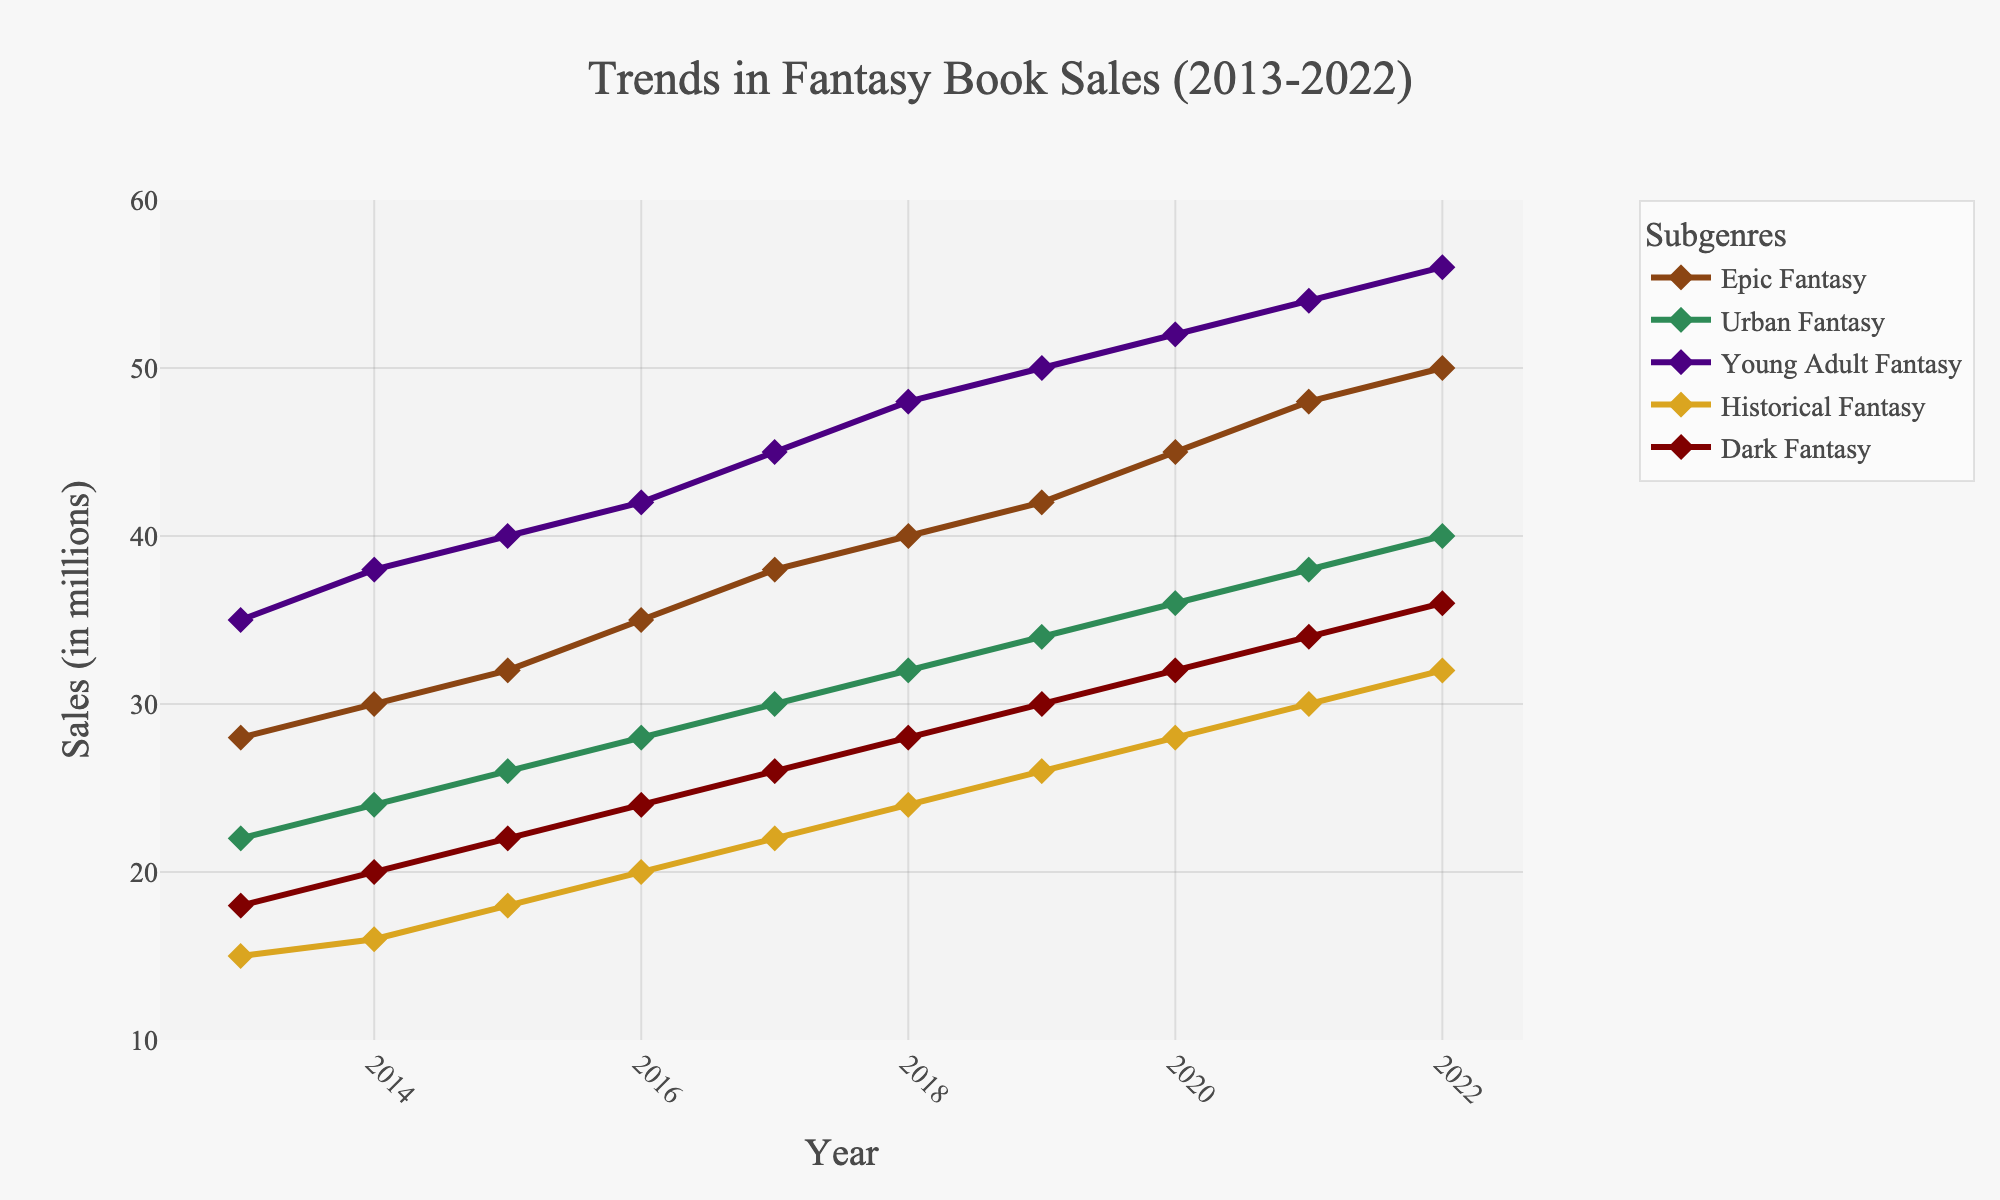What's the trend of Epic Fantasy sales from 2013 to 2022? The data for Epic Fantasy sales shows a steady increase over the years from 28 million in 2013 to 50 million in 2022. This indicates a positive trend.
Answer: Positive trend Which subgenre had the highest sales in 2016? Looking at the figure, the subgenre with the highest sales in 2016 is Young Adult Fantasy with sales of 42 million.
Answer: Young Adult Fantasy By how much did Urban Fantasy sales increase from 2013 to 2022? Urban Fantasy sales increased from 22 million in 2013 to 40 million in 2022. Thus, the increase is: 40 - 22 = 18 million.
Answer: 18 million Compare the sales of Historical Fantasy and Dark Fantasy in 2018. Which was higher and by how much? In 2018, Historical Fantasy had sales of 24 million, and Dark Fantasy had sales of 28 million. Dark Fantasy sales were higher by 28 - 24 = 4 million.
Answer: Dark Fantasy by 4 million Which subgenre consistently performed the best throughout the decade? By examining the trends, Young Adult Fantasy consistently had the highest sales each year, peaking at 56 million in 2022.
Answer: Young Adult Fantasy Calculate the average sales for Dark Fantasy from 2013 to 2022. The sales for Dark Fantasy are 18, 20, 22, 24, 26, 28, 30, 32, 34, 36 million. The average is calculated as: (18 + 20 + 22 + 24 + 26 + 28 + 30 + 32 + 34 + 36) / 10 = 270 / 10 = 27 million.
Answer: 27 million In which year did Epic Fantasy sales cross the 40 million mark? According to the figure, Epic Fantasy sales crossed the 40 million mark in 2018, when they reached 40 million.
Answer: 2018 Which two subgenres showed the smallest difference in sales in 2019? In 2019, the sales are 42, 34, 50, 26, and 30 million for Epic, Urban, Young Adult, Historical, and Dark Fantasy respectively. The smallest difference is between Historical and Dark Fantasy: 30 - 26 = 4 million.
Answer: Historical Fantasy and Dark Fantasy What color represents Urban Fantasy on the chart? According to the custom color palette used in the figure, Urban Fantasy is represented by green.
Answer: Green 